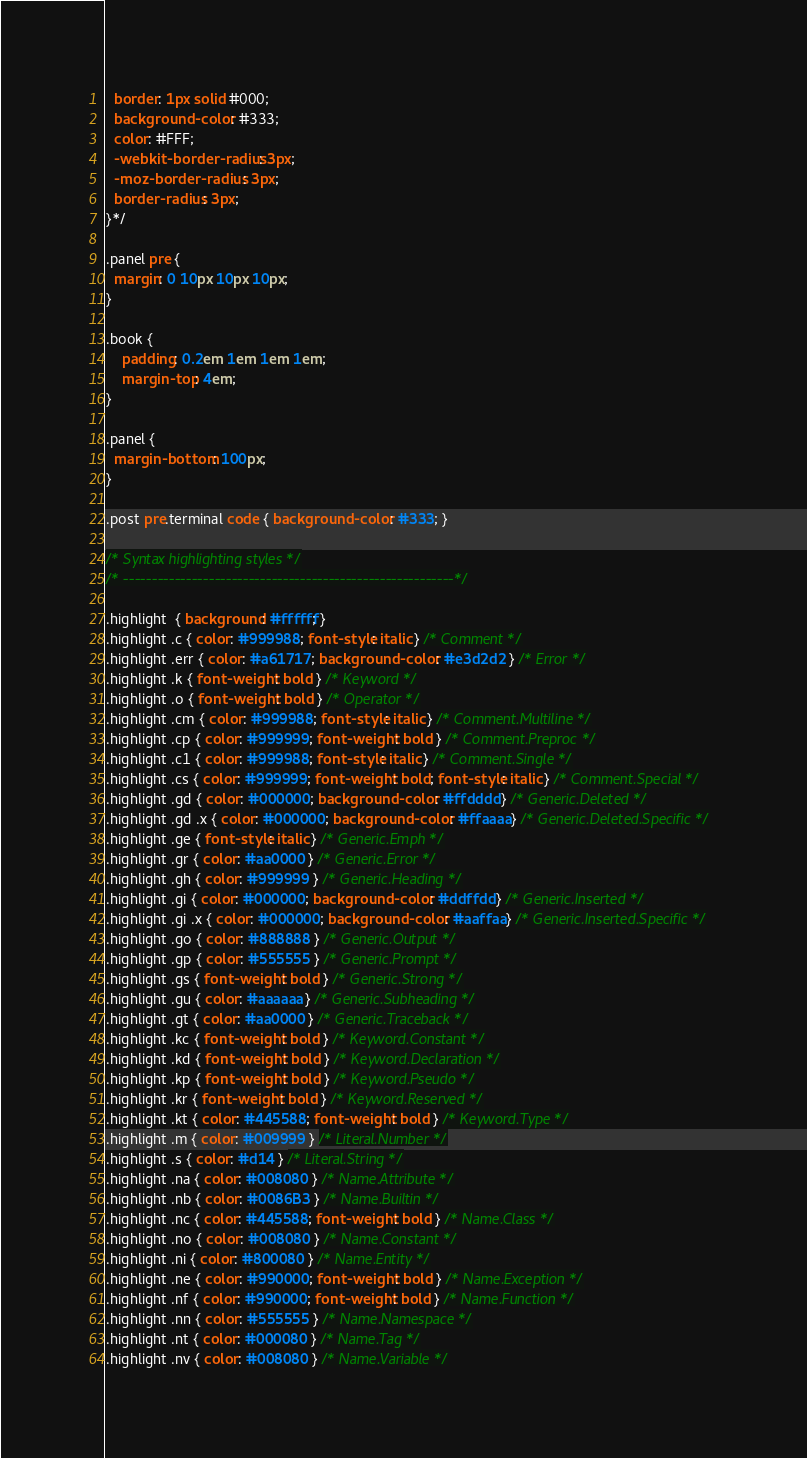Convert code to text. <code><loc_0><loc_0><loc_500><loc_500><_CSS_>  border: 1px solid #000;
  background-color: #333;
  color: #FFF;
  -webkit-border-radius: 3px;
  -moz-border-radius: 3px;
  border-radius: 3px;
}*/

.panel pre {
  margin: 0 10px 10px 10px;
}

.book {
	padding: 0.2em 1em 1em 1em;
	margin-top: 4em;
}

.panel {
  margin-bottom: 100px;
}

.post pre.terminal code { background-color: #333; }

/* Syntax highlighting styles */
/* ----------------------------------------------------------*/

.highlight  { background: #ffffff; }
.highlight .c { color: #999988; font-style: italic } /* Comment */
.highlight .err { color: #a61717; background-color: #e3d2d2 } /* Error */
.highlight .k { font-weight: bold } /* Keyword */
.highlight .o { font-weight: bold } /* Operator */
.highlight .cm { color: #999988; font-style: italic } /* Comment.Multiline */
.highlight .cp { color: #999999; font-weight: bold } /* Comment.Preproc */
.highlight .c1 { color: #999988; font-style: italic } /* Comment.Single */
.highlight .cs { color: #999999; font-weight: bold; font-style: italic } /* Comment.Special */
.highlight .gd { color: #000000; background-color: #ffdddd } /* Generic.Deleted */
.highlight .gd .x { color: #000000; background-color: #ffaaaa } /* Generic.Deleted.Specific */
.highlight .ge { font-style: italic } /* Generic.Emph */
.highlight .gr { color: #aa0000 } /* Generic.Error */
.highlight .gh { color: #999999 } /* Generic.Heading */
.highlight .gi { color: #000000; background-color: #ddffdd } /* Generic.Inserted */
.highlight .gi .x { color: #000000; background-color: #aaffaa } /* Generic.Inserted.Specific */
.highlight .go { color: #888888 } /* Generic.Output */
.highlight .gp { color: #555555 } /* Generic.Prompt */
.highlight .gs { font-weight: bold } /* Generic.Strong */
.highlight .gu { color: #aaaaaa } /* Generic.Subheading */
.highlight .gt { color: #aa0000 } /* Generic.Traceback */
.highlight .kc { font-weight: bold } /* Keyword.Constant */
.highlight .kd { font-weight: bold } /* Keyword.Declaration */
.highlight .kp { font-weight: bold } /* Keyword.Pseudo */
.highlight .kr { font-weight: bold } /* Keyword.Reserved */
.highlight .kt { color: #445588; font-weight: bold } /* Keyword.Type */
.highlight .m { color: #009999 } /* Literal.Number */
.highlight .s { color: #d14 } /* Literal.String */
.highlight .na { color: #008080 } /* Name.Attribute */
.highlight .nb { color: #0086B3 } /* Name.Builtin */
.highlight .nc { color: #445588; font-weight: bold } /* Name.Class */
.highlight .no { color: #008080 } /* Name.Constant */
.highlight .ni { color: #800080 } /* Name.Entity */
.highlight .ne { color: #990000; font-weight: bold } /* Name.Exception */
.highlight .nf { color: #990000; font-weight: bold } /* Name.Function */
.highlight .nn { color: #555555 } /* Name.Namespace */
.highlight .nt { color: #000080 } /* Name.Tag */
.highlight .nv { color: #008080 } /* Name.Variable */</code> 